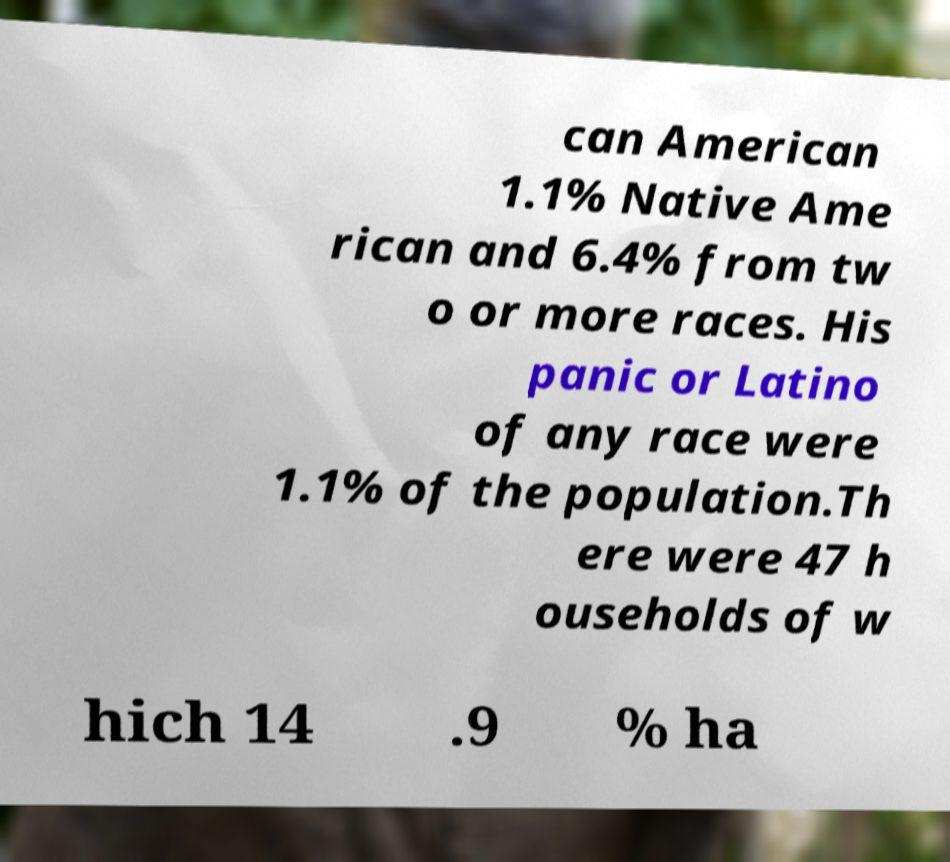Can you accurately transcribe the text from the provided image for me? can American 1.1% Native Ame rican and 6.4% from tw o or more races. His panic or Latino of any race were 1.1% of the population.Th ere were 47 h ouseholds of w hich 14 .9 % ha 